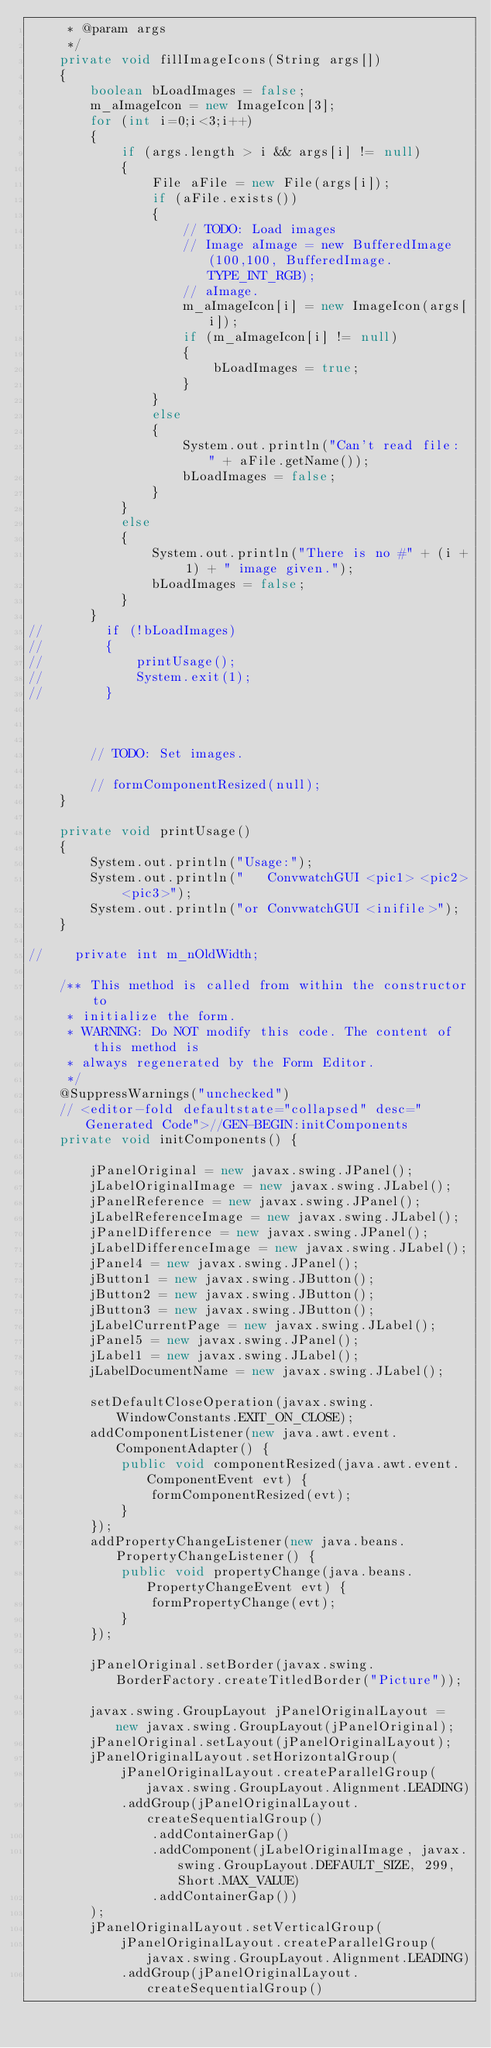<code> <loc_0><loc_0><loc_500><loc_500><_Java_>     * @param args
     */
    private void fillImageIcons(String args[])
    {
        boolean bLoadImages = false;
        m_aImageIcon = new ImageIcon[3];
        for (int i=0;i<3;i++)
        {
            if (args.length > i && args[i] != null)
            {
                File aFile = new File(args[i]);
                if (aFile.exists())
                {
                    // TODO: Load images
                    // Image aImage = new BufferedImage(100,100, BufferedImage.TYPE_INT_RGB);
                    // aImage.
                    m_aImageIcon[i] = new ImageIcon(args[i]);
                    if (m_aImageIcon[i] != null)
                    {
                        bLoadImages = true;
                    }
                }
                else
                {
                    System.out.println("Can't read file: " + aFile.getName());
                    bLoadImages = false;
                }
            }
            else
            {
                System.out.println("There is no #" + (i + 1) + " image given.");
                bLoadImages = false;
            }
        }
//        if (!bLoadImages)
//        {
//            printUsage();
//            System.exit(1);
//        }



        // TODO: Set images.

        // formComponentResized(null);
    }

    private void printUsage()
    {
        System.out.println("Usage:");
        System.out.println("   ConvwatchGUI <pic1> <pic2> <pic3>");
        System.out.println("or ConvwatchGUI <inifile>");
    }

//    private int m_nOldWidth;
    
    /** This method is called from within the constructor to
     * initialize the form.
     * WARNING: Do NOT modify this code. The content of this method is
     * always regenerated by the Form Editor.
     */
    @SuppressWarnings("unchecked")
    // <editor-fold defaultstate="collapsed" desc="Generated Code">//GEN-BEGIN:initComponents
    private void initComponents() {

        jPanelOriginal = new javax.swing.JPanel();
        jLabelOriginalImage = new javax.swing.JLabel();
        jPanelReference = new javax.swing.JPanel();
        jLabelReferenceImage = new javax.swing.JLabel();
        jPanelDifference = new javax.swing.JPanel();
        jLabelDifferenceImage = new javax.swing.JLabel();
        jPanel4 = new javax.swing.JPanel();
        jButton1 = new javax.swing.JButton();
        jButton2 = new javax.swing.JButton();
        jButton3 = new javax.swing.JButton();
        jLabelCurrentPage = new javax.swing.JLabel();
        jPanel5 = new javax.swing.JPanel();
        jLabel1 = new javax.swing.JLabel();
        jLabelDocumentName = new javax.swing.JLabel();

        setDefaultCloseOperation(javax.swing.WindowConstants.EXIT_ON_CLOSE);
        addComponentListener(new java.awt.event.ComponentAdapter() {
            public void componentResized(java.awt.event.ComponentEvent evt) {
                formComponentResized(evt);
            }
        });
        addPropertyChangeListener(new java.beans.PropertyChangeListener() {
            public void propertyChange(java.beans.PropertyChangeEvent evt) {
                formPropertyChange(evt);
            }
        });

        jPanelOriginal.setBorder(javax.swing.BorderFactory.createTitledBorder("Picture"));

        javax.swing.GroupLayout jPanelOriginalLayout = new javax.swing.GroupLayout(jPanelOriginal);
        jPanelOriginal.setLayout(jPanelOriginalLayout);
        jPanelOriginalLayout.setHorizontalGroup(
            jPanelOriginalLayout.createParallelGroup(javax.swing.GroupLayout.Alignment.LEADING)
            .addGroup(jPanelOriginalLayout.createSequentialGroup()
                .addContainerGap()
                .addComponent(jLabelOriginalImage, javax.swing.GroupLayout.DEFAULT_SIZE, 299, Short.MAX_VALUE)
                .addContainerGap())
        );
        jPanelOriginalLayout.setVerticalGroup(
            jPanelOriginalLayout.createParallelGroup(javax.swing.GroupLayout.Alignment.LEADING)
            .addGroup(jPanelOriginalLayout.createSequentialGroup()</code> 